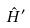<formula> <loc_0><loc_0><loc_500><loc_500>\hat { H } ^ { \prime }</formula> 